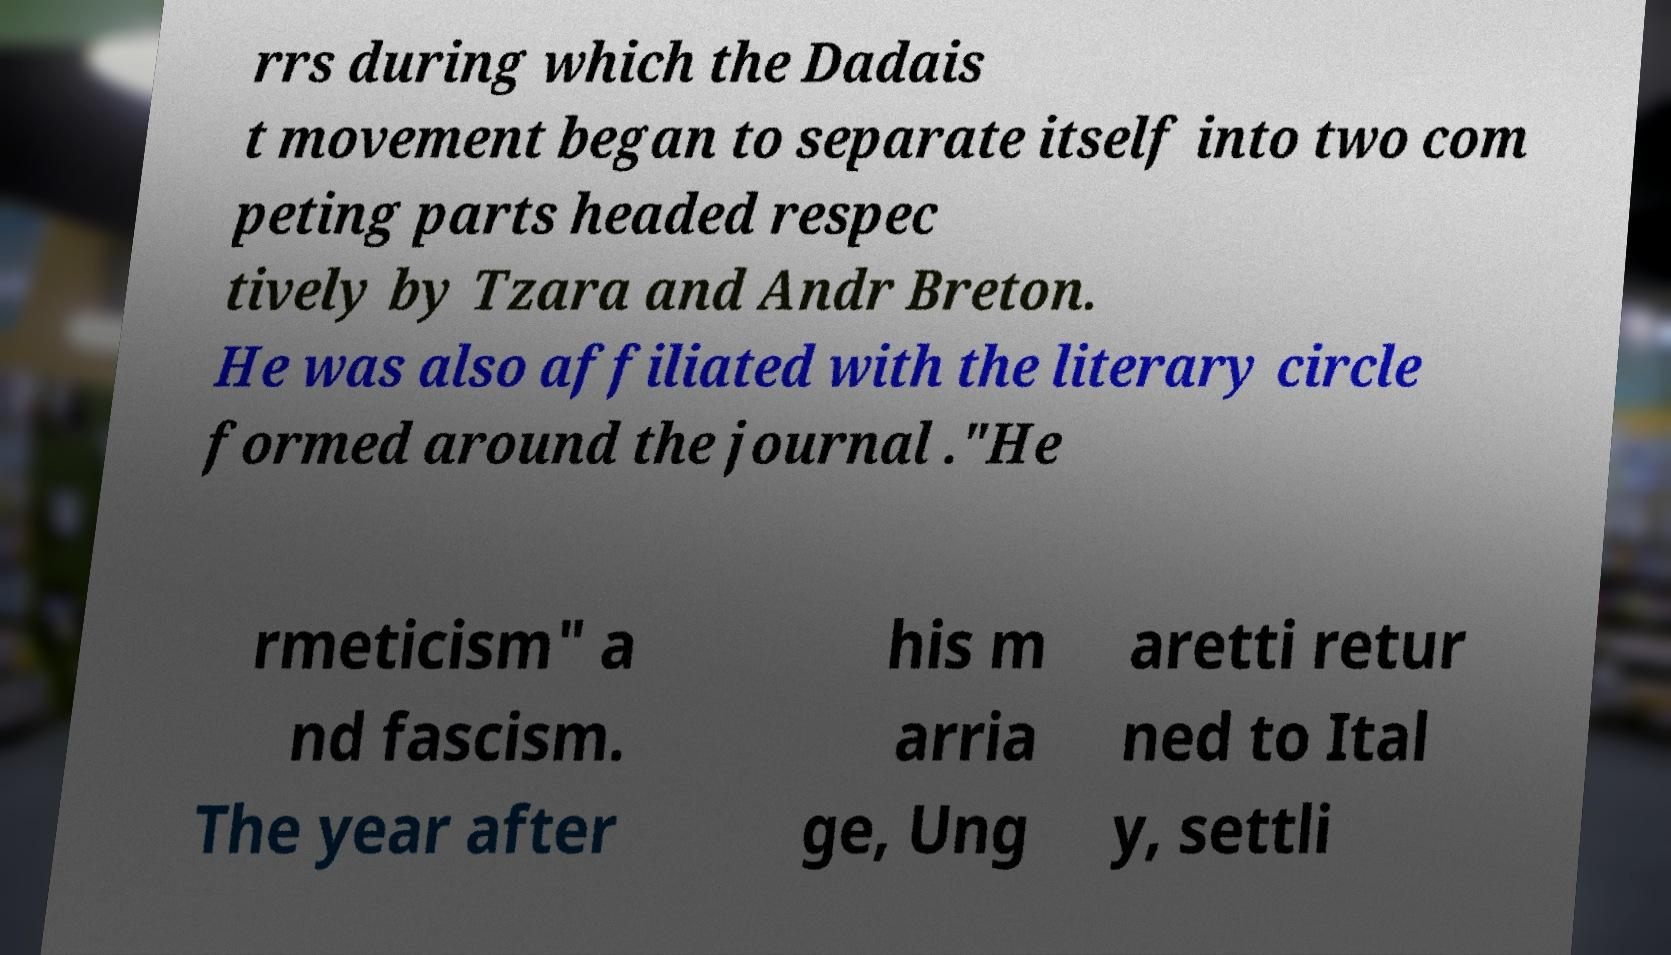I need the written content from this picture converted into text. Can you do that? rrs during which the Dadais t movement began to separate itself into two com peting parts headed respec tively by Tzara and Andr Breton. He was also affiliated with the literary circle formed around the journal ."He rmeticism" a nd fascism. The year after his m arria ge, Ung aretti retur ned to Ital y, settli 